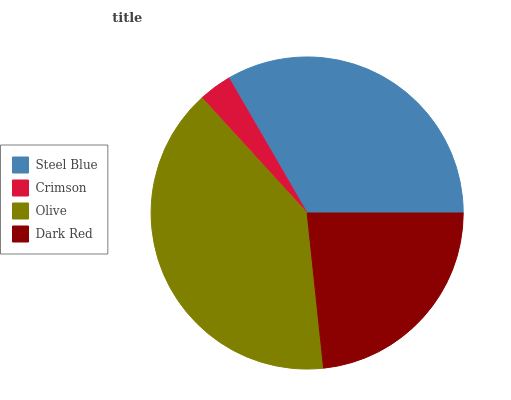Is Crimson the minimum?
Answer yes or no. Yes. Is Olive the maximum?
Answer yes or no. Yes. Is Olive the minimum?
Answer yes or no. No. Is Crimson the maximum?
Answer yes or no. No. Is Olive greater than Crimson?
Answer yes or no. Yes. Is Crimson less than Olive?
Answer yes or no. Yes. Is Crimson greater than Olive?
Answer yes or no. No. Is Olive less than Crimson?
Answer yes or no. No. Is Steel Blue the high median?
Answer yes or no. Yes. Is Dark Red the low median?
Answer yes or no. Yes. Is Olive the high median?
Answer yes or no. No. Is Steel Blue the low median?
Answer yes or no. No. 